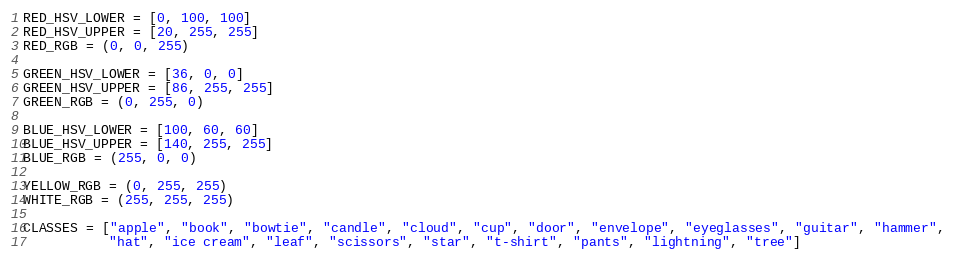Convert code to text. <code><loc_0><loc_0><loc_500><loc_500><_Python_>RED_HSV_LOWER = [0, 100, 100]
RED_HSV_UPPER = [20, 255, 255]
RED_RGB = (0, 0, 255)

GREEN_HSV_LOWER = [36, 0, 0]
GREEN_HSV_UPPER = [86, 255, 255]
GREEN_RGB = (0, 255, 0)

BLUE_HSV_LOWER = [100, 60, 60]
BLUE_HSV_UPPER = [140, 255, 255]
BLUE_RGB = (255, 0, 0)

YELLOW_RGB = (0, 255, 255)
WHITE_RGB = (255, 255, 255)

CLASSES = ["apple", "book", "bowtie", "candle", "cloud", "cup", "door", "envelope", "eyeglasses", "guitar", "hammer",
           "hat", "ice cream", "leaf", "scissors", "star", "t-shirt", "pants", "lightning", "tree"]
</code> 